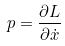Convert formula to latex. <formula><loc_0><loc_0><loc_500><loc_500>p = \frac { \partial L } { \partial \dot { x } }</formula> 